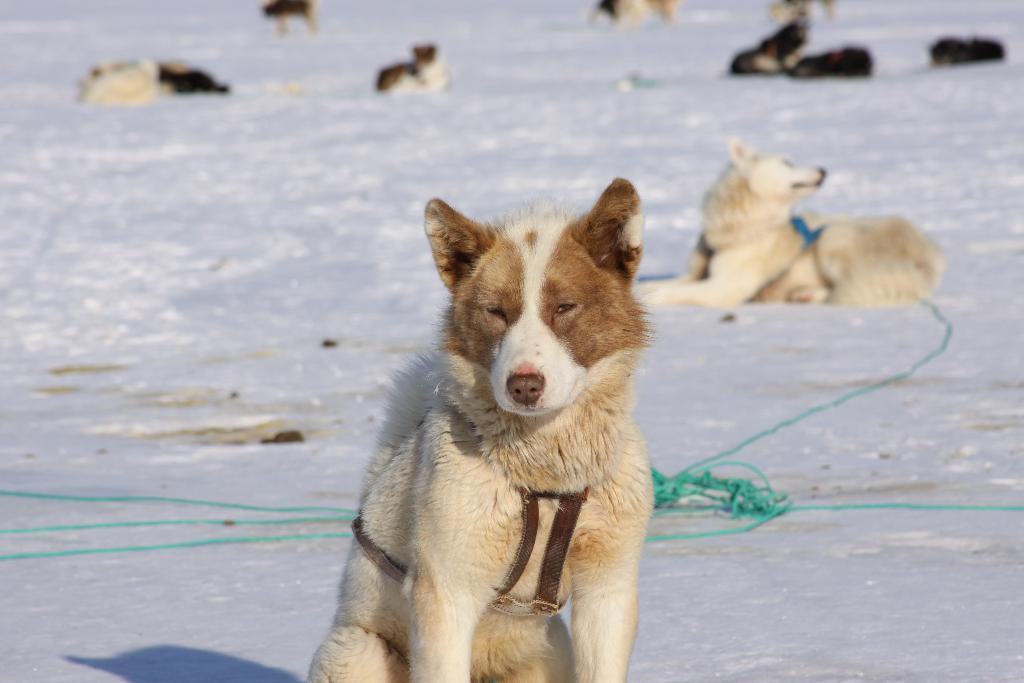What types of living organisms can be seen in the image? There are animals in the image. What objects are present at the bottom of the image? There are ropes at the bottom of the image. What type of hill can be seen in the background of the image? There is no hill visible in the image; it only features animals and ropes. What color is the skirt worn by the animal in the image? There are no animals wearing skirts in the image, as the animals do not have clothing. 